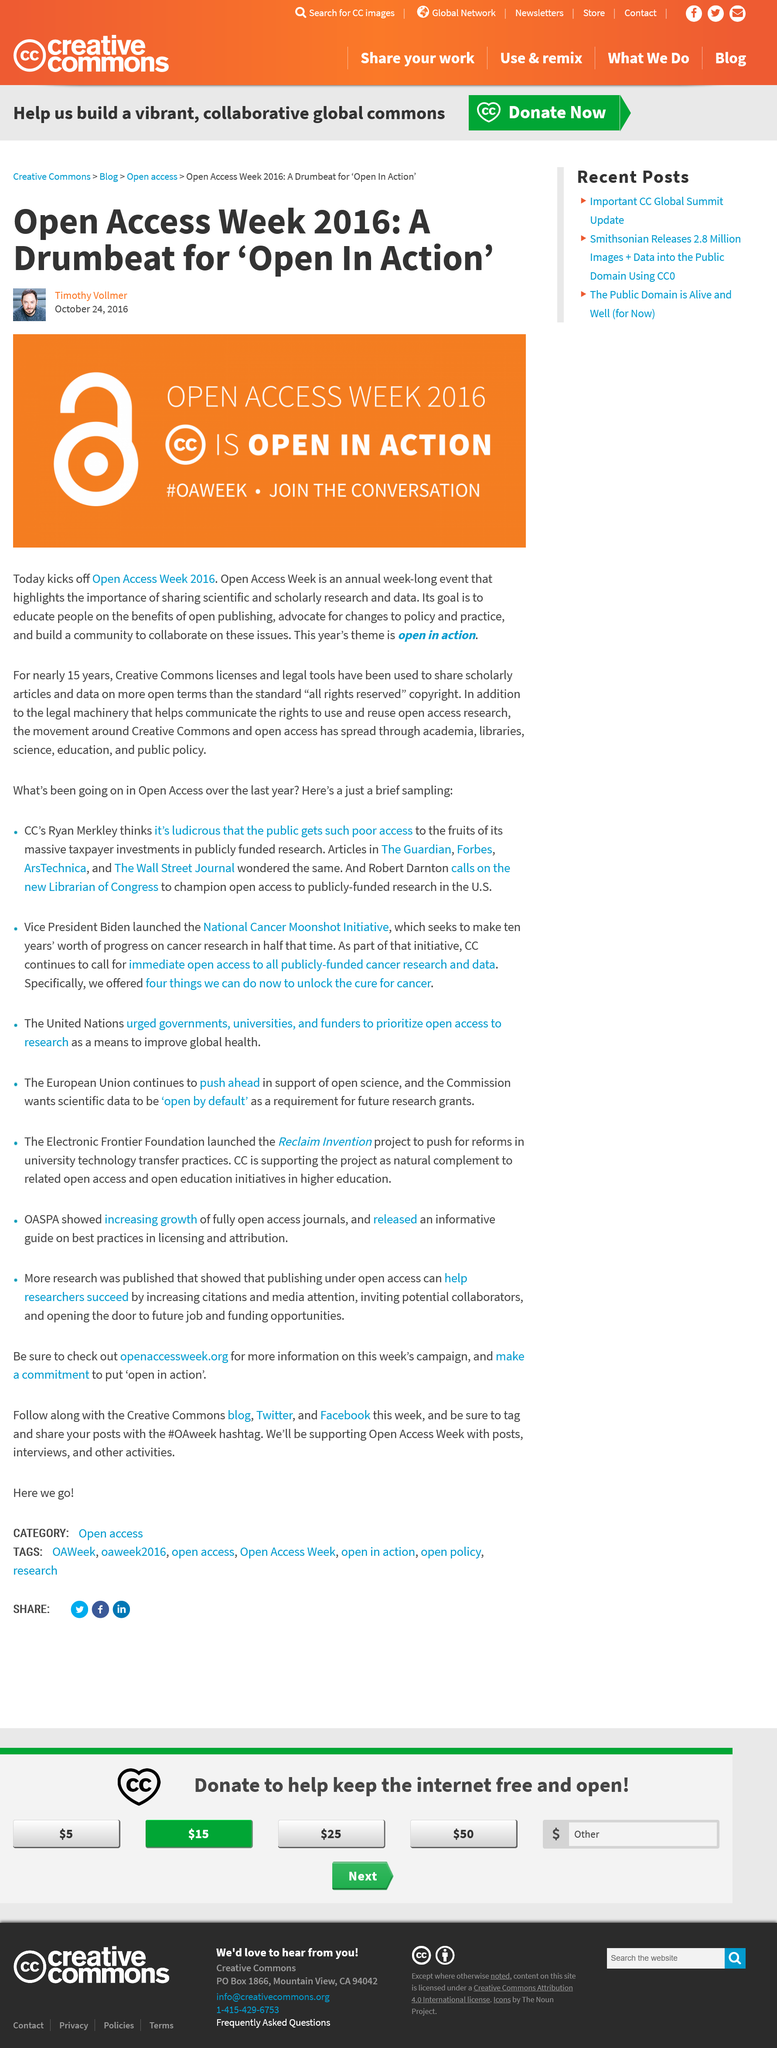Mention a couple of crucial points in this snapshot. This year's theme in Open Access Week 2016 is "open in action. Open Access Week 2016 was written by Timothy Vollmer, who is known for his article 'A Drumbeat for ‘Open In Action’.' Open Access Week is an annual event that promotes the sharing and accessibility of scientific and scholarly research data to the public. 